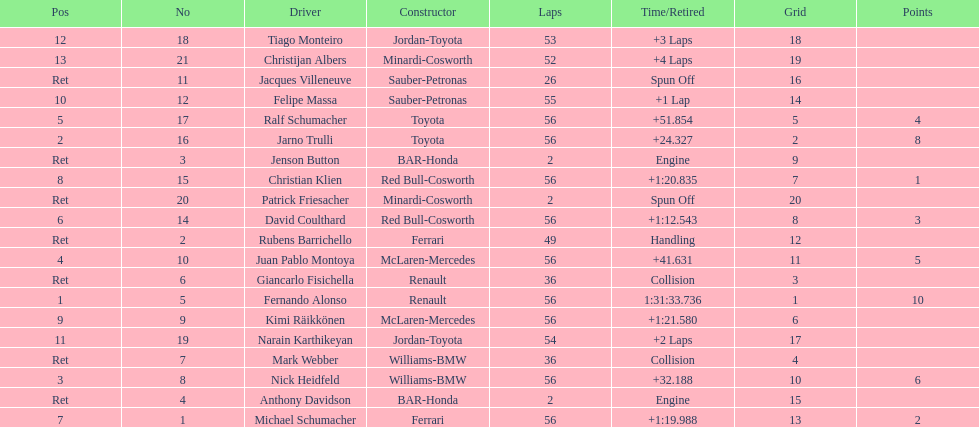What driver finished first? Fernando Alonso. 